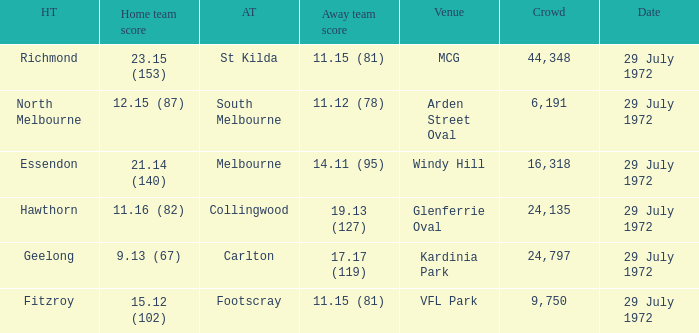When did the offsite team footscray accomplish 1 29 July 1972. Write the full table. {'header': ['HT', 'Home team score', 'AT', 'Away team score', 'Venue', 'Crowd', 'Date'], 'rows': [['Richmond', '23.15 (153)', 'St Kilda', '11.15 (81)', 'MCG', '44,348', '29 July 1972'], ['North Melbourne', '12.15 (87)', 'South Melbourne', '11.12 (78)', 'Arden Street Oval', '6,191', '29 July 1972'], ['Essendon', '21.14 (140)', 'Melbourne', '14.11 (95)', 'Windy Hill', '16,318', '29 July 1972'], ['Hawthorn', '11.16 (82)', 'Collingwood', '19.13 (127)', 'Glenferrie Oval', '24,135', '29 July 1972'], ['Geelong', '9.13 (67)', 'Carlton', '17.17 (119)', 'Kardinia Park', '24,797', '29 July 1972'], ['Fitzroy', '15.12 (102)', 'Footscray', '11.15 (81)', 'VFL Park', '9,750', '29 July 1972']]} 